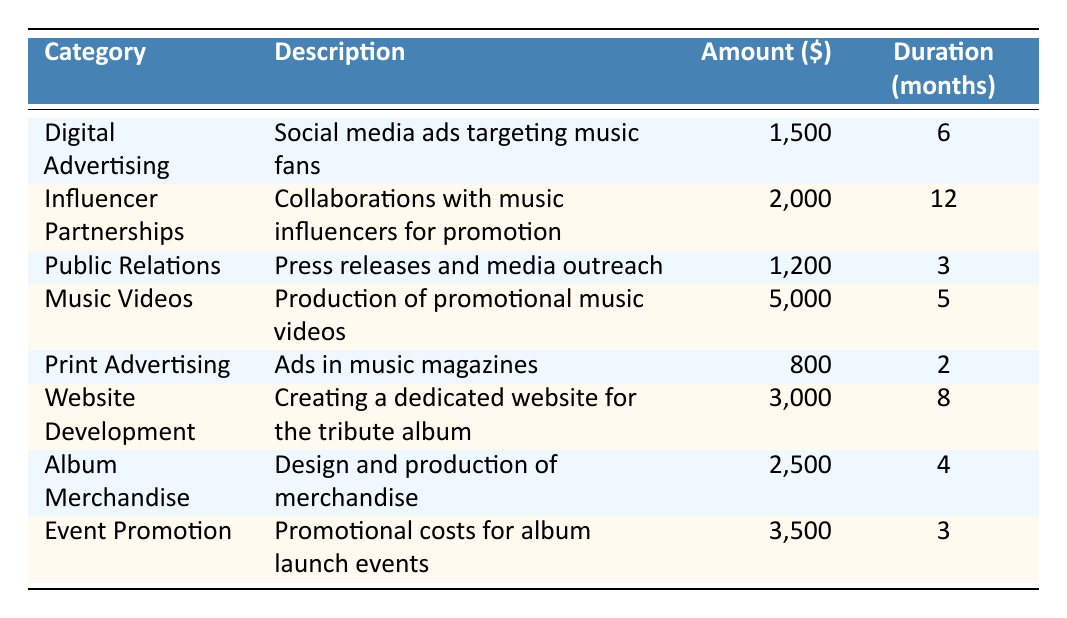How much is spent on Digital Advertising? The table shows that the amount for Digital Advertising is listed under the "Amount" column next to the "Digital Advertising" category, which is $1,500.
Answer: 1500 What is the duration for Influencer Partnerships? The duration for Influencer Partnerships is given in the "Duration (months)" column, which is 12 months.
Answer: 12 How much more is spent on Music Videos than Print Advertising? From the table, Music Videos costs $5,000, and Print Advertising costs $800. The difference is calculated as 5000 - 800 = 4200.
Answer: 4200 Is the total spending on Album Merchandise greater than the combined spending on Public Relations and Print Advertising? The total spending on Album Merchandise is $2,500. The combined spending on Public Relations ($1,200) and Print Advertising ($800) is $1,200 + $800 = $2,000. Since $2,500 is greater than $2,000, the statement is true.
Answer: Yes What is the overall marketing budget for the first three months? The expenses for the first three months include Public Relations ($1,200) and Event Promotion ($3,500). Summing these amounts gives: 1,200 + 3,500 = $4,700.
Answer: 4700 What is the average amount spent per month for Website Development? The total amount spent on Website Development is $3,000 over 8 months. To find the average, divide the total amount by the duration: 3000 / 8 = 375.
Answer: 375 How many marketing categories have a spending amount of $2,500 or more? The categories with spending of $2,500 or more are Influencer Partnerships ($2,000), Music Videos ($5,000), Website Development ($3,000), and Album Merchandise ($2,500). That's a total of 4 categories.
Answer: 4 Is the total duration of all marketing expenses equal to or greater than 30 months? The sum of all durations is 6 + 12 + 3 + 5 + 2 + 8 + 4 + 3 = 43 months. Since 43 is greater than 30, the statement is true.
Answer: Yes Which category has the highest marketing expense? Looking at the "Amount" column, Music Videos has the highest expense, which is $5,000.
Answer: 5000 